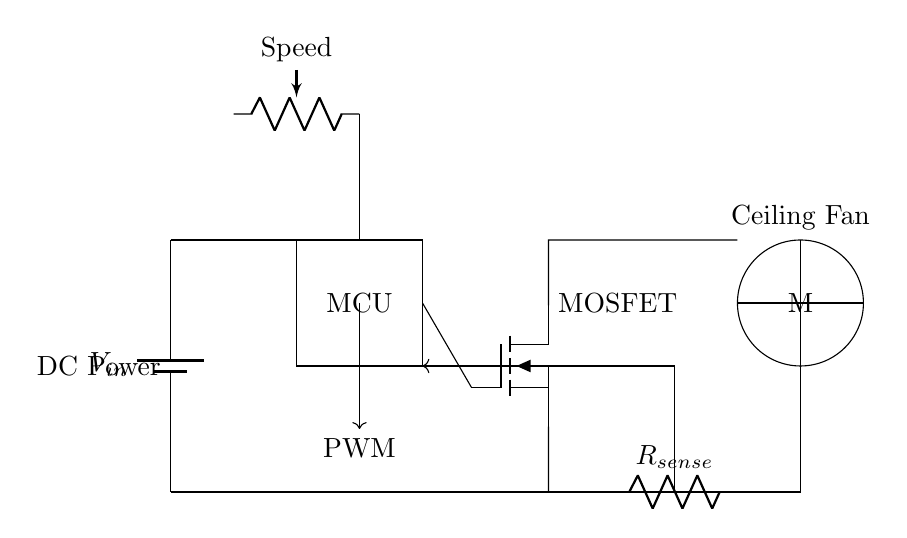What type of motor is used in this circuit? The circuit diagram indicates a DC motor is depicted as a circle labeled M. This identification is based on the standard symbols used in circuit diagrams to represent different components.
Answer: DC motor What is the function of the MOSFET in this circuit? The MOSFET is used as a switching element that controls the power delivered to the DC motor based on the PWM signal from the microcontroller. This can be deduced from its connections and role in regulating current through the motor.
Answer: Switch What controls the speed of the ceiling fan? The speed of the ceiling fan is controlled by the speed potentiometer which is connected to the microcontroller, enabling variable resistance adjustments that affect the PWM output to the MOSFET, therefore modulating motor speed.
Answer: Potentiometer What component provides feedback to the microcontroller? The current sense resistor, labeled R sense, provides feedback by measuring the current flowing through the motor. This feedback is essential for the microcontroller to adjust the PWM signal accordingly and maintain desired motor performance.
Answer: Current sense resistor What does the PWM label indicate in the circuit? The PWM label indicates the pulse-width modulation signal that controls the MOSFET, which in turn regulates the speed of the DC motor by controlling the average power delivered to it. This modulation is key for efficient operation of the ceiling fan.
Answer: Pulse-width modulation How does the DC power supply connect to the motor? The DC power supply is connected through the microcontroller to the MOSFET, which then connects to the motor. The analysis of the flow shows that the power from the supply drives the motor indirectly through the MOSFET when it is activated by the control signals.
Answer: Directly through the MOSFET 